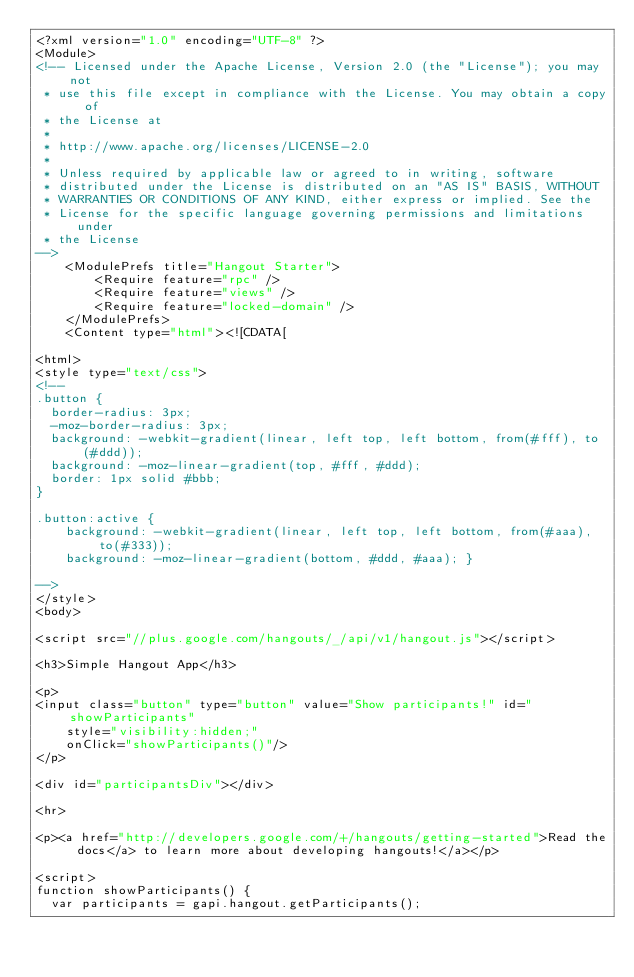<code> <loc_0><loc_0><loc_500><loc_500><_XML_><?xml version="1.0" encoding="UTF-8" ?>
<Module>
<!-- Licensed under the Apache License, Version 2.0 (the "License"); you may not
 * use this file except in compliance with the License. You may obtain a copy of
 * the License at
 *
 * http://www.apache.org/licenses/LICENSE-2.0
 *	
 * Unless required by applicable law or agreed to in writing, software
 * distributed under the License is distributed on an "AS IS" BASIS, WITHOUT
 * WARRANTIES OR CONDITIONS OF ANY KIND, either express or implied. See the
 * License for the specific language governing permissions and limitations under
 * the License
-->
	<ModulePrefs title="Hangout Starter">
		<Require feature="rpc" />
		<Require feature="views" />
		<Require feature="locked-domain" />
	</ModulePrefs>
	<Content type="html"><![CDATA[     

<html>
<style type="text/css">
<!--
.button {
  border-radius: 3px;
  -moz-border-radius: 3px;
  background: -webkit-gradient(linear, left top, left bottom, from(#fff), to(#ddd));
  background: -moz-linear-gradient(top, #fff, #ddd);  
  border: 1px solid #bbb;
}

.button:active {
	background: -webkit-gradient(linear, left top, left bottom, from(#aaa), to(#333)); 
	background: -moz-linear-gradient(bottom, #ddd, #aaa); }

-->
</style>
<body>

<script src="//plus.google.com/hangouts/_/api/v1/hangout.js"></script>

<h3>Simple Hangout App</h3>

<p>
<input class="button" type="button" value="Show participants!" id="showParticipants" 
    style="visibility:hidden;"
    onClick="showParticipants()"/>
</p>

<div id="participantsDiv"></div>

<hr>

<p><a href="http://developers.google.com/+/hangouts/getting-started">Read the docs</a> to learn more about developing hangouts!</a></p>

<script>
function showParticipants() {
  var participants = gapi.hangout.getParticipants();
</code> 